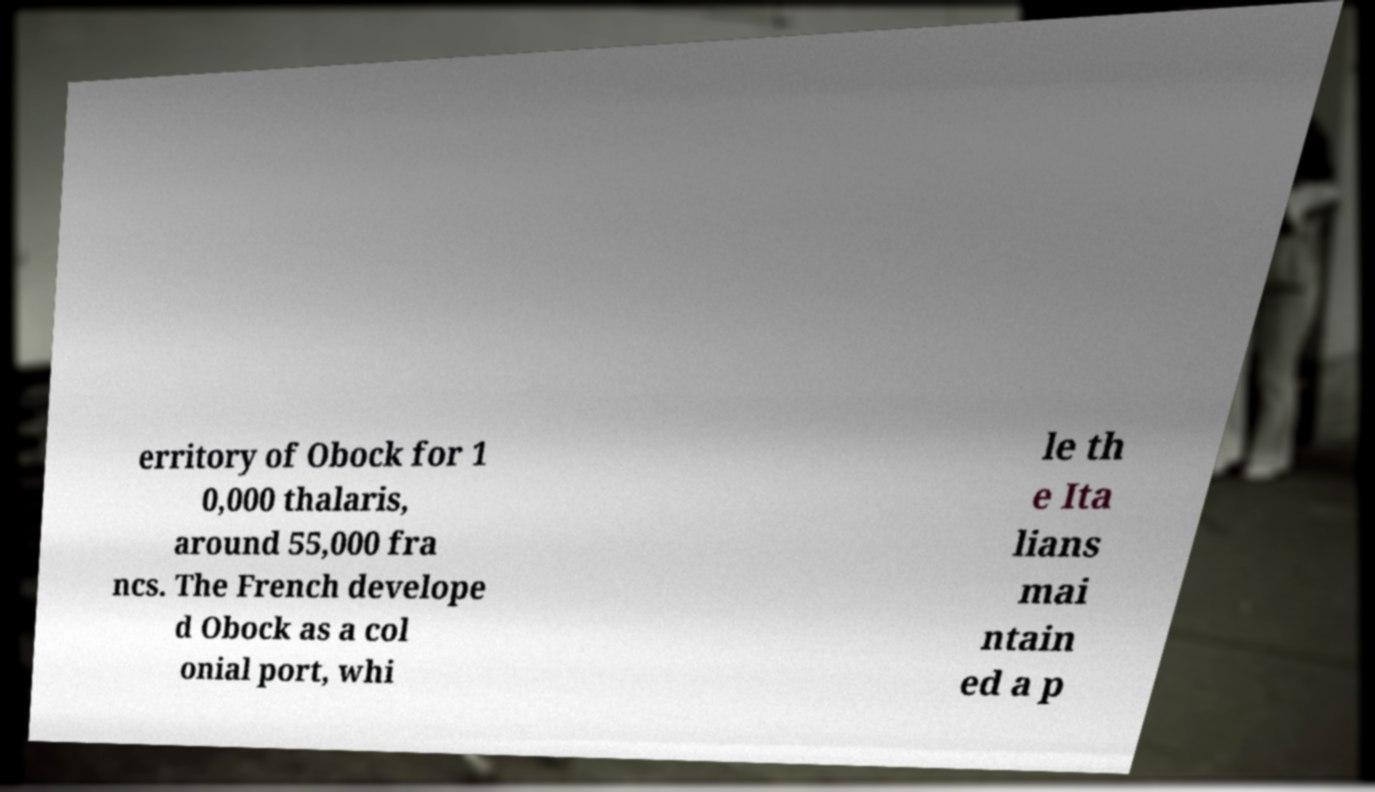For documentation purposes, I need the text within this image transcribed. Could you provide that? erritory of Obock for 1 0,000 thalaris, around 55,000 fra ncs. The French develope d Obock as a col onial port, whi le th e Ita lians mai ntain ed a p 